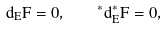<formula> <loc_0><loc_0><loc_500><loc_500>d _ { E } F = 0 , \quad ^ { * } d _ { E } ^ { * } F = 0 ,</formula> 